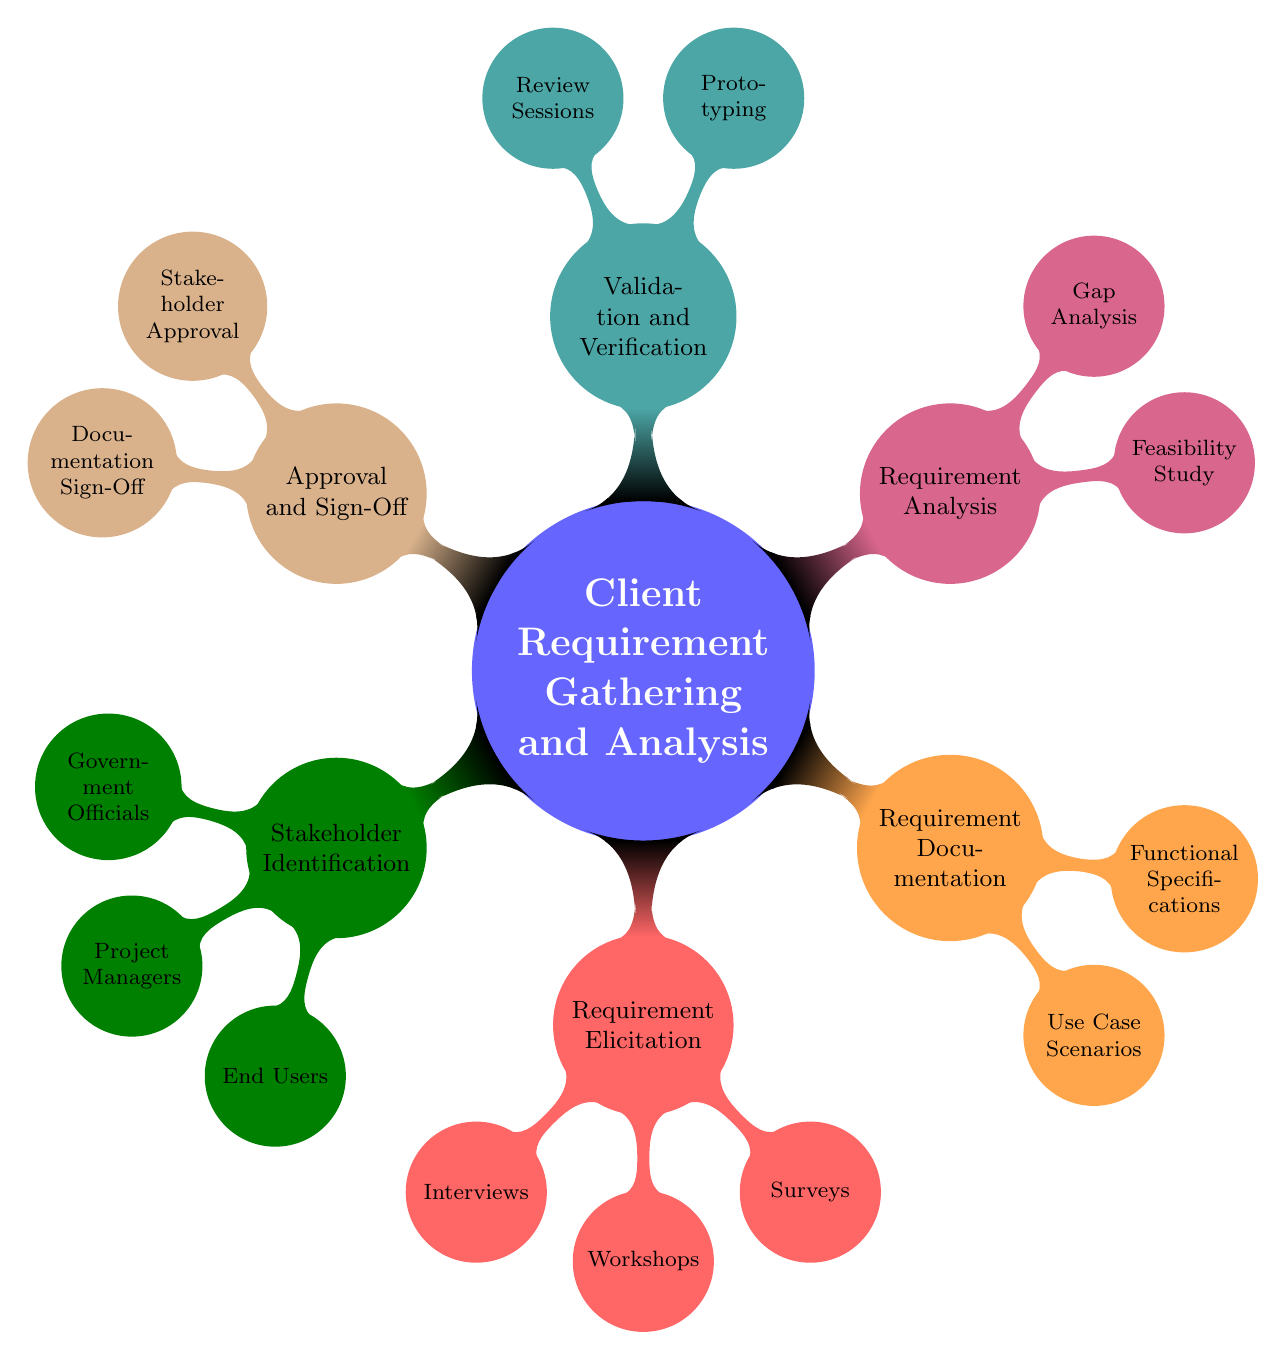What is the first major node in the diagram? The first major node in the diagram is "Client Requirement Gathering and Analysis." This is the central theme from which all other nodes and sub-nodes branch out.
Answer: Client Requirement Gathering and Analysis How many nodes are there under "Requirement Elicitation"? Under the "Requirement Elicitation" node, there are three sub-nodes: "Interviews," "Workshops," and "Surveys." Each of these represents a method for gathering requirements.
Answer: 3 Which node is directly related to "Stakeholder Approval"? The node directly related to "Stakeholder Approval" is "Approval and Sign-Off." This shows that stakeholder approval is a component of the overall approval process.
Answer: Approval and Sign-Off What type of document is associated with "Functional Specifications"? The type of document associated with "Functional Specifications" is a "standardized format," indicated in the context of documentation related to functional requirements.
Answer: standardized format What process is used to validate the understanding of requirements? The process used to validate the understanding of requirements is "Prototyping." This is a method that allows stakeholders to visually assess the requirements.
Answer: Prototyping How does "Gap Analysis" relate to the overall requirement process? "Gap Analysis" is part of the "Requirement Analysis" step in the overall requirement process. It helps identify any missing or conflicting requirements that must be addressed for successful project implementation.
Answer: Requirement Analysis What is the relationship between "Surveys" and "Requirement Elicitation"? "Surveys" is a sub-node of "Requirement Elicitation," which means it is one of the methods used to gather requirements from stakeholders.
Answer: Requirement Elicitation How many sub-nodes are there under "Validation and Verification"? There are two sub-nodes under "Validation and Verification," which are "Prototyping" and "Review Sessions." Both are methods used in the validation and verification stage.
Answer: 2 What is the final step before project implementation in the diagram? The final step before project implementation in the diagram is "Approval and Sign-Off." This signifies that all required approvals must be obtained before proceeding.
Answer: Approval and Sign-Off 